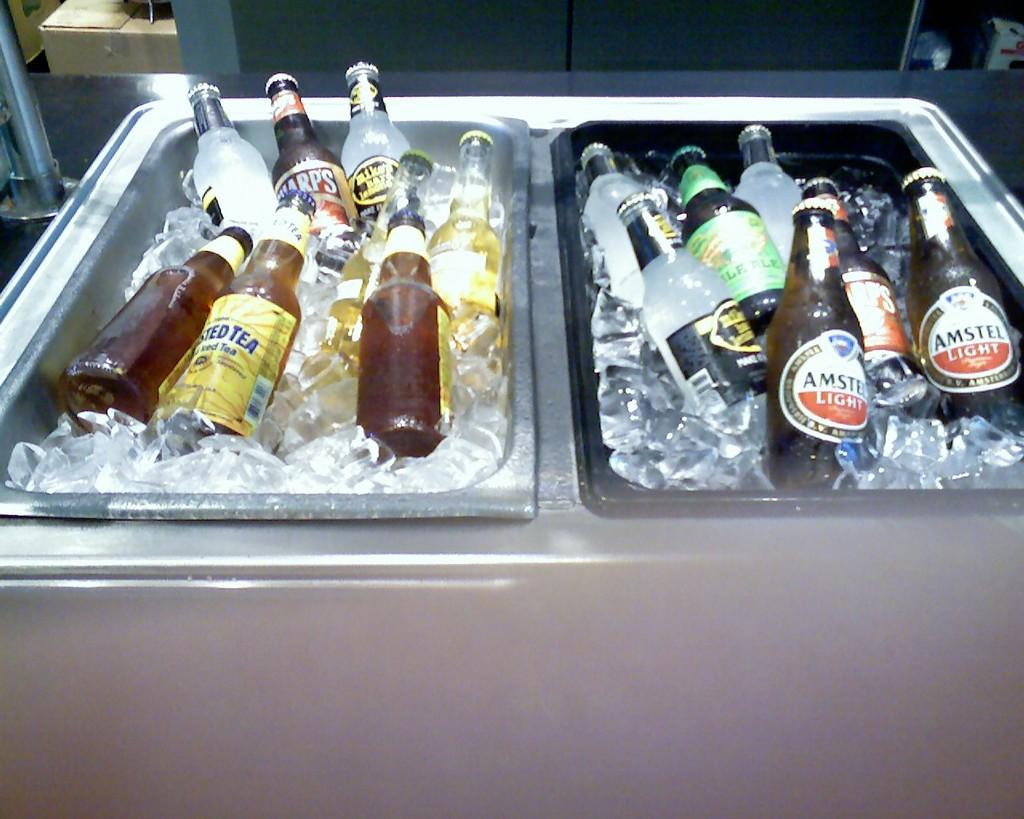<image>
Present a compact description of the photo's key features. Two tubs of ice holding different brands of alcoholic drinks ranging from Mike's Hard Lemonade to Amstel Light beer. 